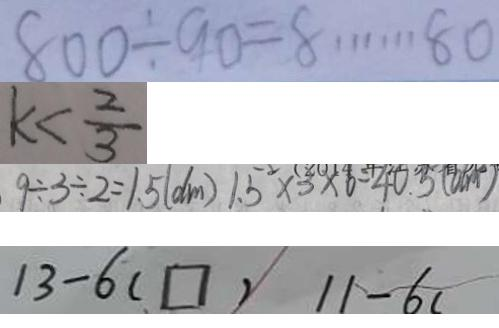<formula> <loc_0><loc_0><loc_500><loc_500>8 0 0 \div 9 0 = 8 \cdots 8 0 
 k < \frac { 2 } { 3 } 
 9 \div 3 \div 2 = 1 . 5 ( d m ) 1 . 5 ^ { 2 } \times 3 \times 6 = 4 0 . 3 ( d m ) 
 1 3 - 6 ( \square ) 1 1 - 6 (</formula> 